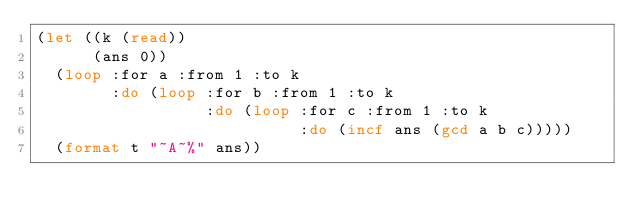<code> <loc_0><loc_0><loc_500><loc_500><_Lisp_>(let ((k (read))
      (ans 0))
  (loop :for a :from 1 :to k
        :do (loop :for b :from 1 :to k
                  :do (loop :for c :from 1 :to k
                            :do (incf ans (gcd a b c)))))
  (format t "~A~%" ans))
</code> 